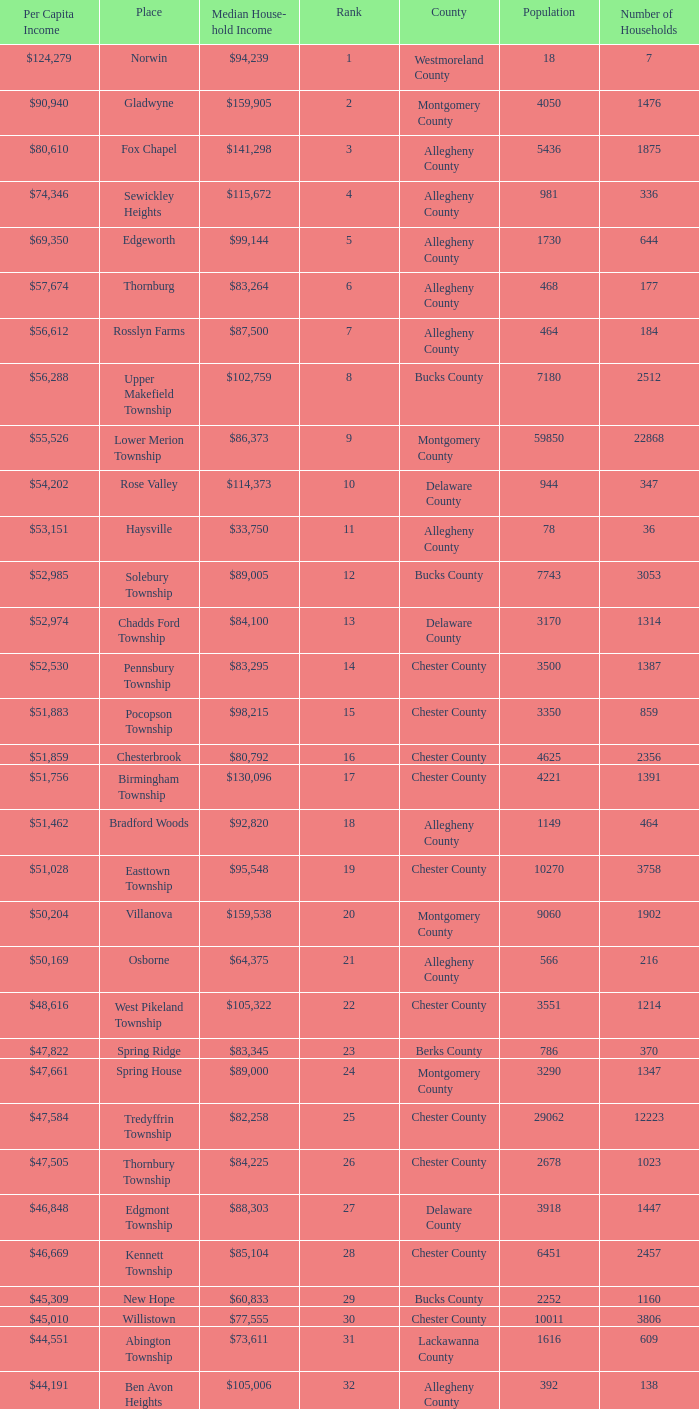Which county has a median household income of  $98,090? Bucks County. 